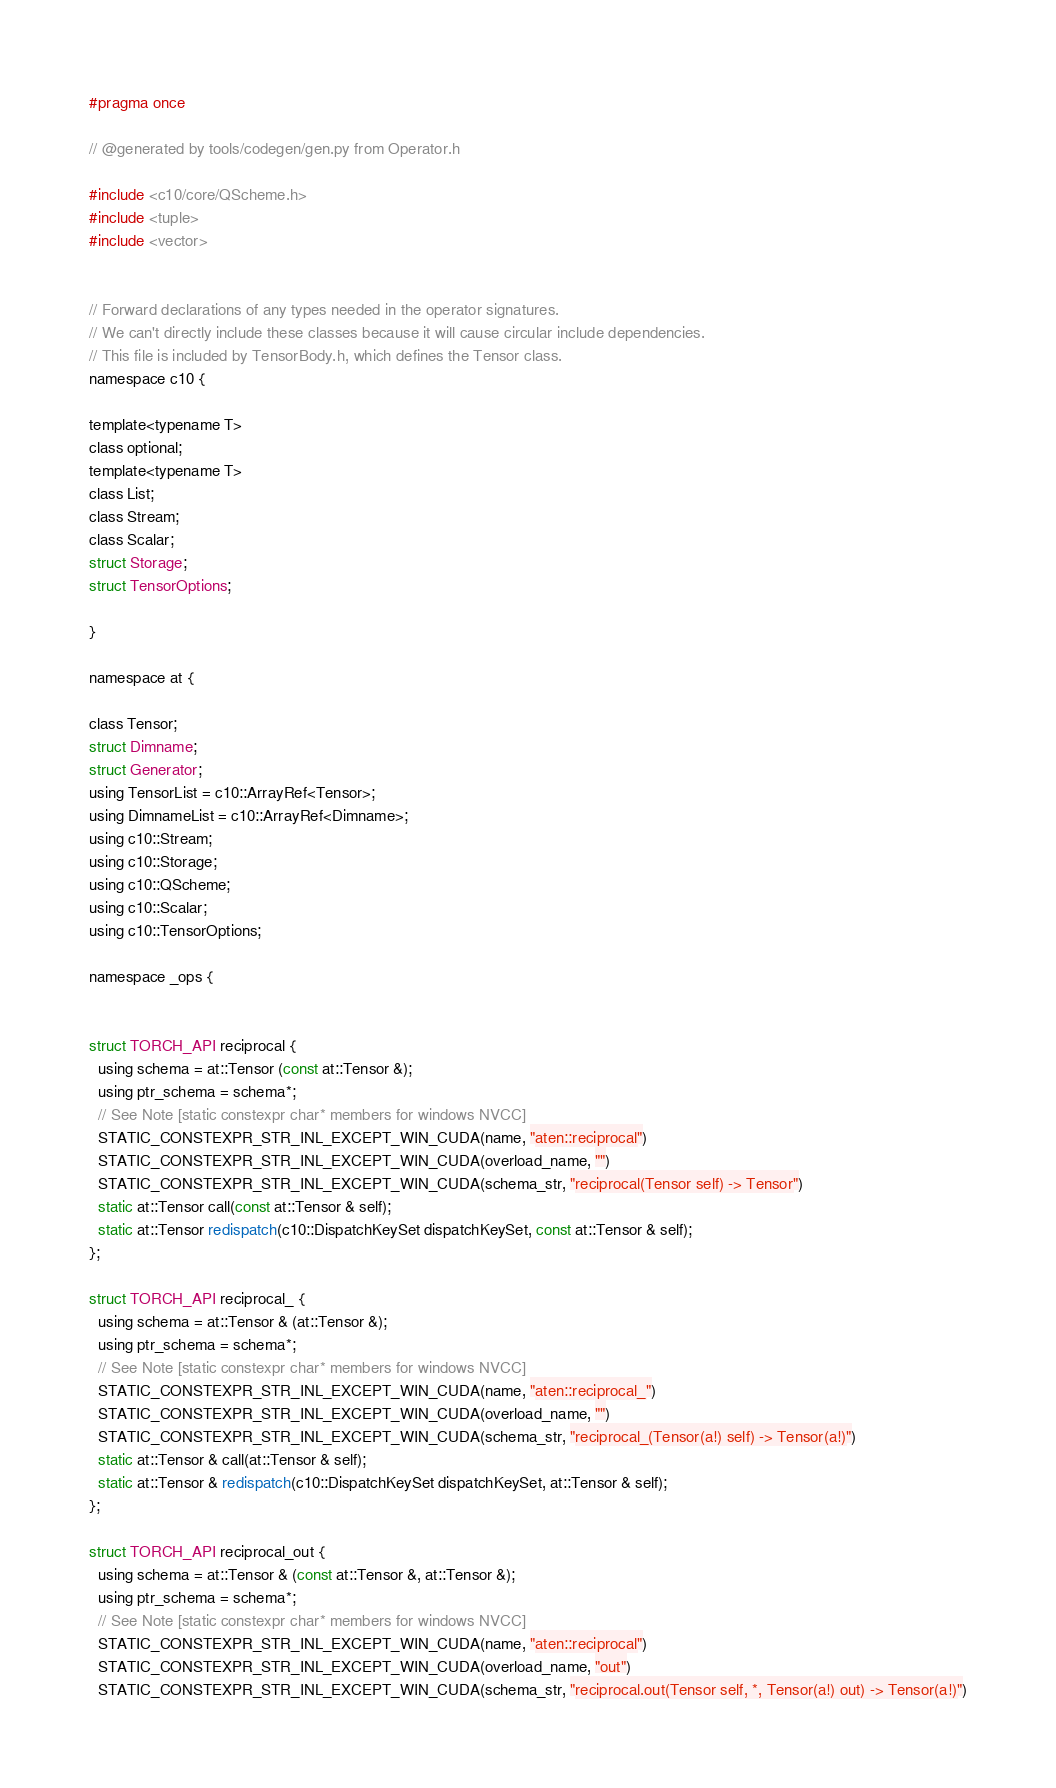<code> <loc_0><loc_0><loc_500><loc_500><_C_>#pragma once

// @generated by tools/codegen/gen.py from Operator.h

#include <c10/core/QScheme.h>
#include <tuple>
#include <vector>


// Forward declarations of any types needed in the operator signatures.
// We can't directly include these classes because it will cause circular include dependencies.
// This file is included by TensorBody.h, which defines the Tensor class.
namespace c10 {

template<typename T>
class optional;
template<typename T>
class List;
class Stream;
class Scalar;
struct Storage;
struct TensorOptions;

}

namespace at {

class Tensor;
struct Dimname;
struct Generator;
using TensorList = c10::ArrayRef<Tensor>;
using DimnameList = c10::ArrayRef<Dimname>;
using c10::Stream;
using c10::Storage;
using c10::QScheme;
using c10::Scalar;
using c10::TensorOptions;

namespace _ops {


struct TORCH_API reciprocal {
  using schema = at::Tensor (const at::Tensor &);
  using ptr_schema = schema*;
  // See Note [static constexpr char* members for windows NVCC]
  STATIC_CONSTEXPR_STR_INL_EXCEPT_WIN_CUDA(name, "aten::reciprocal")
  STATIC_CONSTEXPR_STR_INL_EXCEPT_WIN_CUDA(overload_name, "")
  STATIC_CONSTEXPR_STR_INL_EXCEPT_WIN_CUDA(schema_str, "reciprocal(Tensor self) -> Tensor")
  static at::Tensor call(const at::Tensor & self);
  static at::Tensor redispatch(c10::DispatchKeySet dispatchKeySet, const at::Tensor & self);
};

struct TORCH_API reciprocal_ {
  using schema = at::Tensor & (at::Tensor &);
  using ptr_schema = schema*;
  // See Note [static constexpr char* members for windows NVCC]
  STATIC_CONSTEXPR_STR_INL_EXCEPT_WIN_CUDA(name, "aten::reciprocal_")
  STATIC_CONSTEXPR_STR_INL_EXCEPT_WIN_CUDA(overload_name, "")
  STATIC_CONSTEXPR_STR_INL_EXCEPT_WIN_CUDA(schema_str, "reciprocal_(Tensor(a!) self) -> Tensor(a!)")
  static at::Tensor & call(at::Tensor & self);
  static at::Tensor & redispatch(c10::DispatchKeySet dispatchKeySet, at::Tensor & self);
};

struct TORCH_API reciprocal_out {
  using schema = at::Tensor & (const at::Tensor &, at::Tensor &);
  using ptr_schema = schema*;
  // See Note [static constexpr char* members for windows NVCC]
  STATIC_CONSTEXPR_STR_INL_EXCEPT_WIN_CUDA(name, "aten::reciprocal")
  STATIC_CONSTEXPR_STR_INL_EXCEPT_WIN_CUDA(overload_name, "out")
  STATIC_CONSTEXPR_STR_INL_EXCEPT_WIN_CUDA(schema_str, "reciprocal.out(Tensor self, *, Tensor(a!) out) -> Tensor(a!)")</code> 